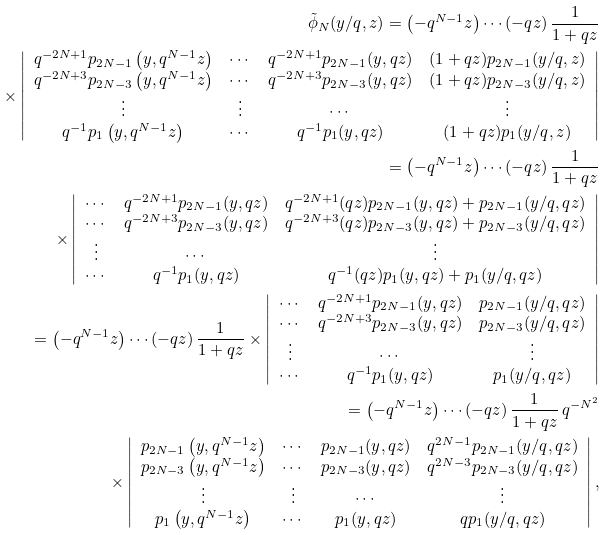<formula> <loc_0><loc_0><loc_500><loc_500>\tilde { \phi } _ { N } ( y / q , z ) = \left ( - q ^ { N - 1 } z \right ) \cdots ( - q z ) \, \frac { 1 } { 1 + q z } \\ \times \left | \begin{array} { c c c c } q ^ { - 2 N + 1 } p _ { 2 N - 1 } \left ( y , q ^ { N - 1 } z \right ) & \cdots & q ^ { - 2 N + 1 } p _ { 2 N - 1 } ( y , q z ) & ( 1 + q z ) p _ { 2 N - 1 } ( y / q , z ) \\ q ^ { - 2 N + 3 } p _ { 2 N - 3 } \left ( y , q ^ { N - 1 } z \right ) & \cdots & q ^ { - 2 N + 3 } p _ { 2 N - 3 } ( y , q z ) & ( 1 + q z ) p _ { 2 N - 3 } ( y / q , z ) \\ \vdots & \vdots & \cdots & \vdots \\ q ^ { - 1 } p _ { 1 } \left ( y , q ^ { N - 1 } z \right ) & \cdots & q ^ { - 1 } p _ { 1 } ( y , q z ) & ( 1 + q z ) p _ { 1 } ( y / q , z ) \end{array} \right | \\ = \left ( - q ^ { N - 1 } z \right ) \cdots ( - q z ) \, \frac { 1 } { 1 + q z } \\ \times \left | \begin{array} { c c c } \cdots & q ^ { - 2 N + 1 } p _ { 2 N - 1 } ( y , q z ) & q ^ { - 2 N + 1 } ( q z ) p _ { 2 N - 1 } ( y , q z ) + p _ { 2 N - 1 } ( y / q , q z ) \\ \cdots & q ^ { - 2 N + 3 } p _ { 2 N - 3 } ( y , q z ) & q ^ { - 2 N + 3 } ( q z ) p _ { 2 N - 3 } ( y , q z ) + p _ { 2 N - 3 } ( y / q , q z ) \\ \vdots & \cdots & \vdots \\ \cdots & q ^ { - 1 } p _ { 1 } ( y , q z ) & q ^ { - 1 } ( q z ) p _ { 1 } ( y , q z ) + p _ { 1 } ( y / q , q z ) \end{array} \right | \\ = \left ( - q ^ { N - 1 } z \right ) \cdots ( - q z ) \, \frac { 1 } { 1 + q z } \times \left | \begin{array} { c c c } \cdots & q ^ { - 2 N + 1 } p _ { 2 N - 1 } ( y , q z ) & p _ { 2 N - 1 } ( y / q , q z ) \\ \cdots & q ^ { - 2 N + 3 } p _ { 2 N - 3 } ( y , q z ) & p _ { 2 N - 3 } ( y / q , q z ) \\ \vdots & \cdots & \vdots \\ \cdots & q ^ { - 1 } p _ { 1 } ( y , q z ) & p _ { 1 } ( y / q , q z ) \end{array} \right | \\ = \left ( - q ^ { N - 1 } z \right ) \cdots ( - q z ) \, \frac { 1 } { 1 + q z } \, q ^ { - N ^ { 2 } } \\ \times \left | \begin{array} { c c c c } p _ { 2 N - 1 } \left ( y , q ^ { N - 1 } z \right ) & \cdots & p _ { 2 N - 1 } ( y , q z ) & q ^ { 2 N - 1 } p _ { 2 N - 1 } ( y / q , q z ) \\ p _ { 2 N - 3 } \left ( y , q ^ { N - 1 } z \right ) & \cdots & p _ { 2 N - 3 } ( y , q z ) & q ^ { 2 N - 3 } p _ { 2 N - 3 } ( y / q , q z ) \\ \vdots & \vdots & \cdots & \vdots \\ p _ { 1 } \left ( y , q ^ { N - 1 } z \right ) & \cdots & p _ { 1 } ( y , q z ) & q p _ { 1 } ( y / q , q z ) \end{array} \right | ,</formula> 